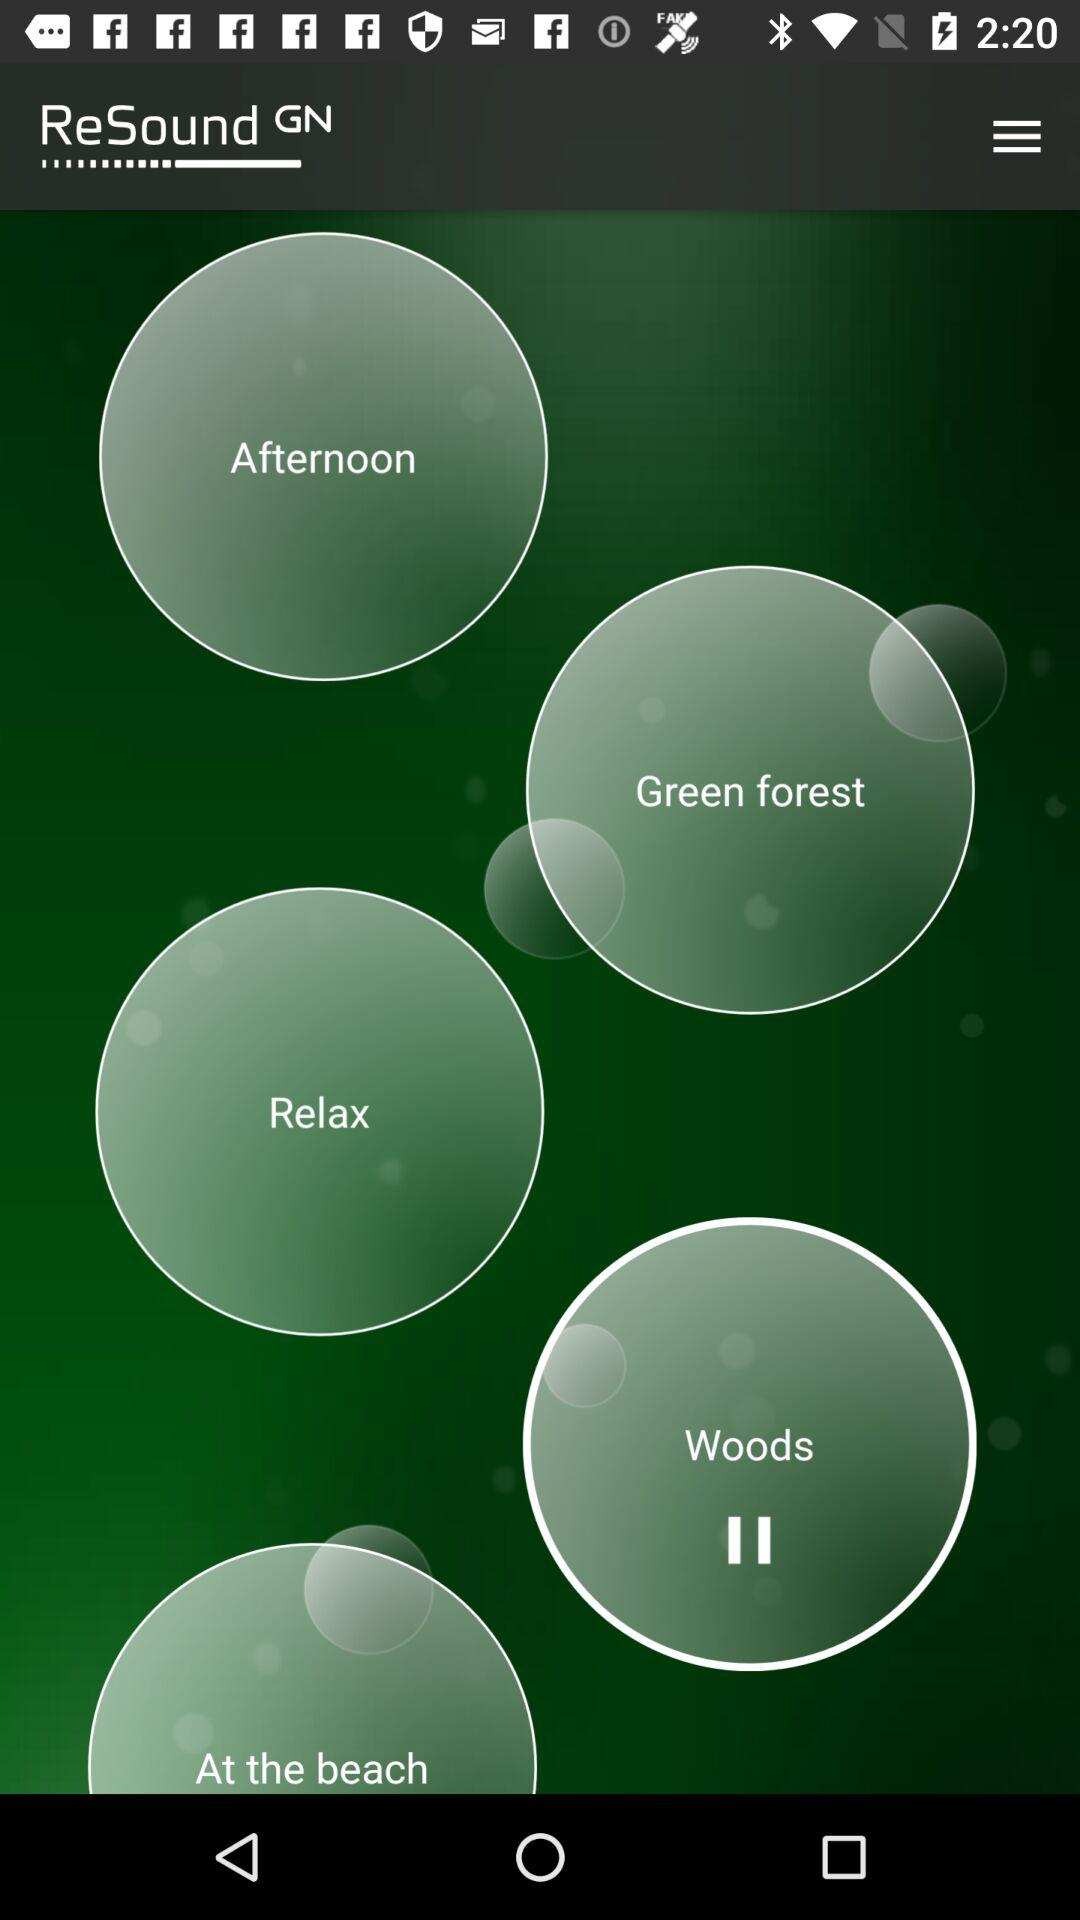What are the different sound options available? The different sound options are "Afternoon", "Green forest", "Relax", "Woods" and "At the beach". 